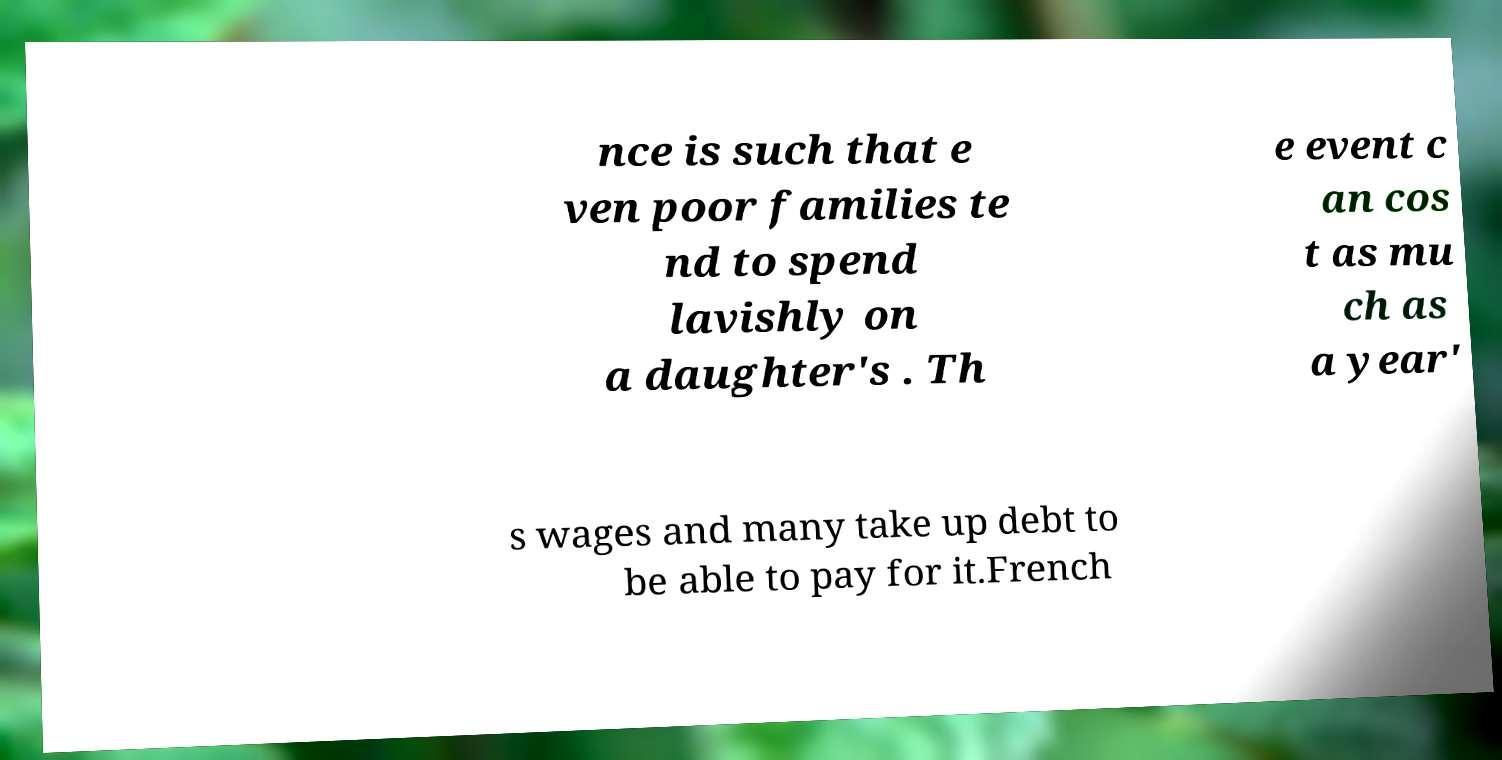There's text embedded in this image that I need extracted. Can you transcribe it verbatim? nce is such that e ven poor families te nd to spend lavishly on a daughter's . Th e event c an cos t as mu ch as a year' s wages and many take up debt to be able to pay for it.French 